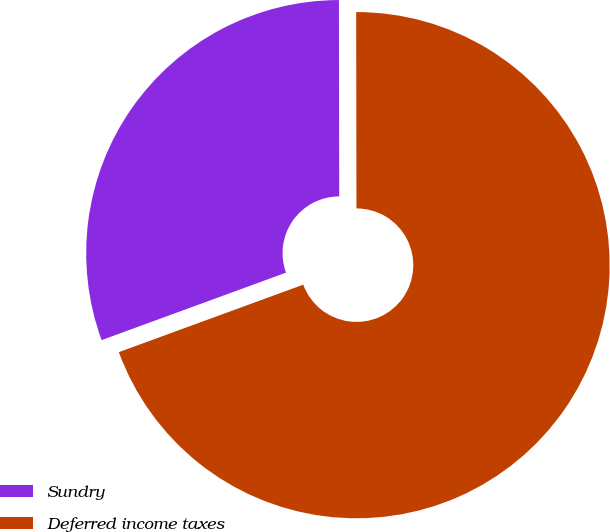Convert chart to OTSL. <chart><loc_0><loc_0><loc_500><loc_500><pie_chart><fcel>Sundry<fcel>Deferred income taxes<nl><fcel>30.56%<fcel>69.44%<nl></chart> 